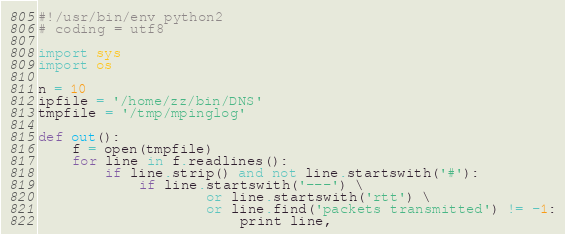<code> <loc_0><loc_0><loc_500><loc_500><_Python_>#!/usr/bin/env python2
# coding = utf8

import sys
import os

n = 10
ipfile = '/home/zz/bin/DNS'
tmpfile = '/tmp/mpinglog'

def out():
    f = open(tmpfile)
    for line in f.readlines():
        if line.strip() and not line.startswith('#'):
            if line.startswith('---') \
                    or line.startswith('rtt') \
                    or line.find('packets transmitted') != -1:
                        print line,
</code> 